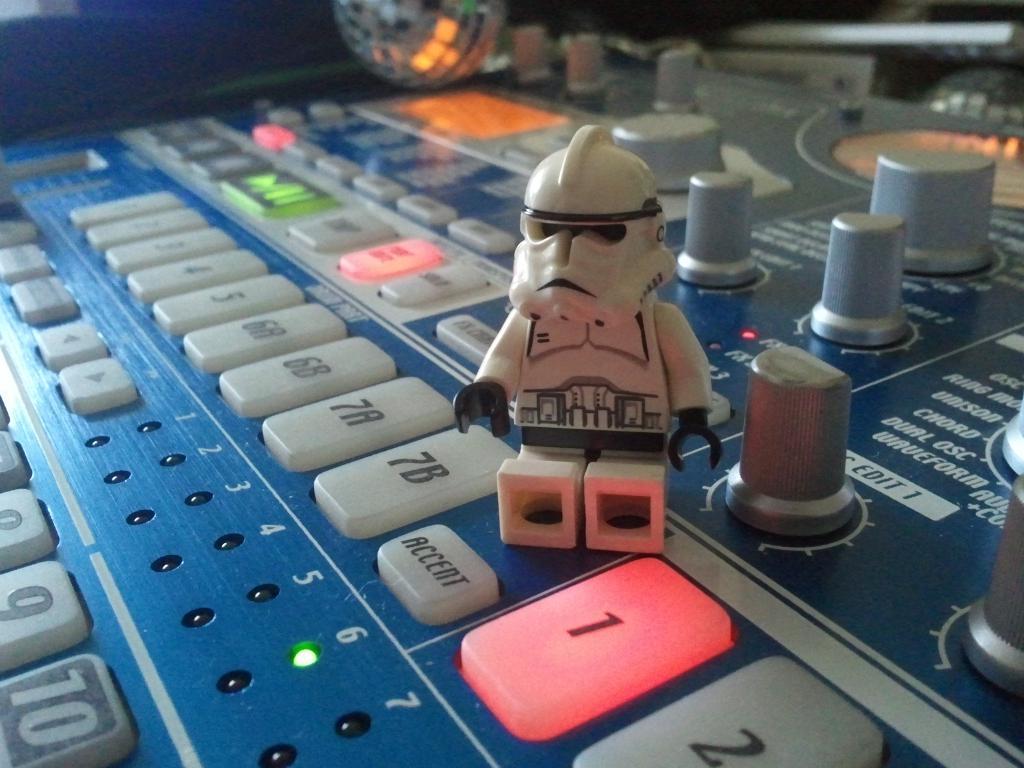What button is red?
Your answer should be very brief. 1. What number is to the right of the red button?
Your answer should be compact. 2. 